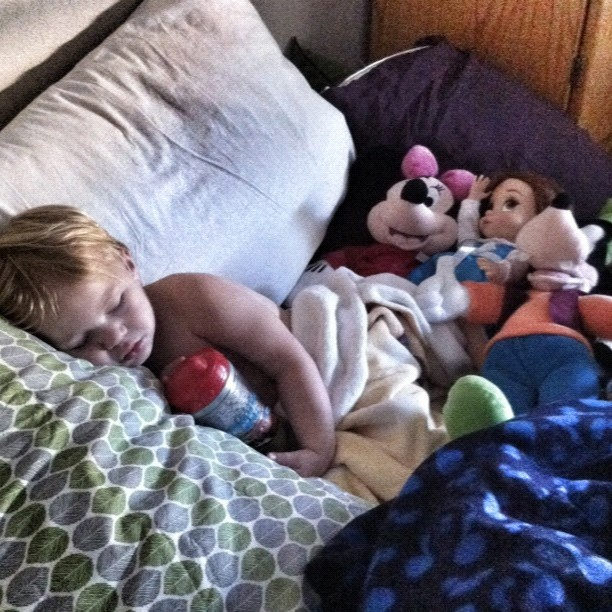Describe the objects in this image and their specific colors. I can see bed in lightgray, black, lavender, darkgray, and gray tones, people in lightgray, black, brown, maroon, and darkgray tones, and cup in lightgray, maroon, black, and gray tones in this image. 